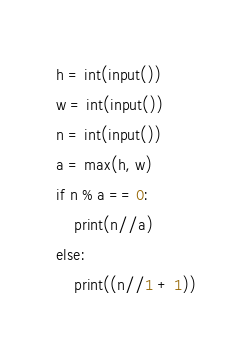<code> <loc_0><loc_0><loc_500><loc_500><_Python_>h = int(input())
w = int(input())
n = int(input())
a = max(h, w)
if n % a == 0:
    print(n//a)
else:
    print((n//1 + 1))</code> 